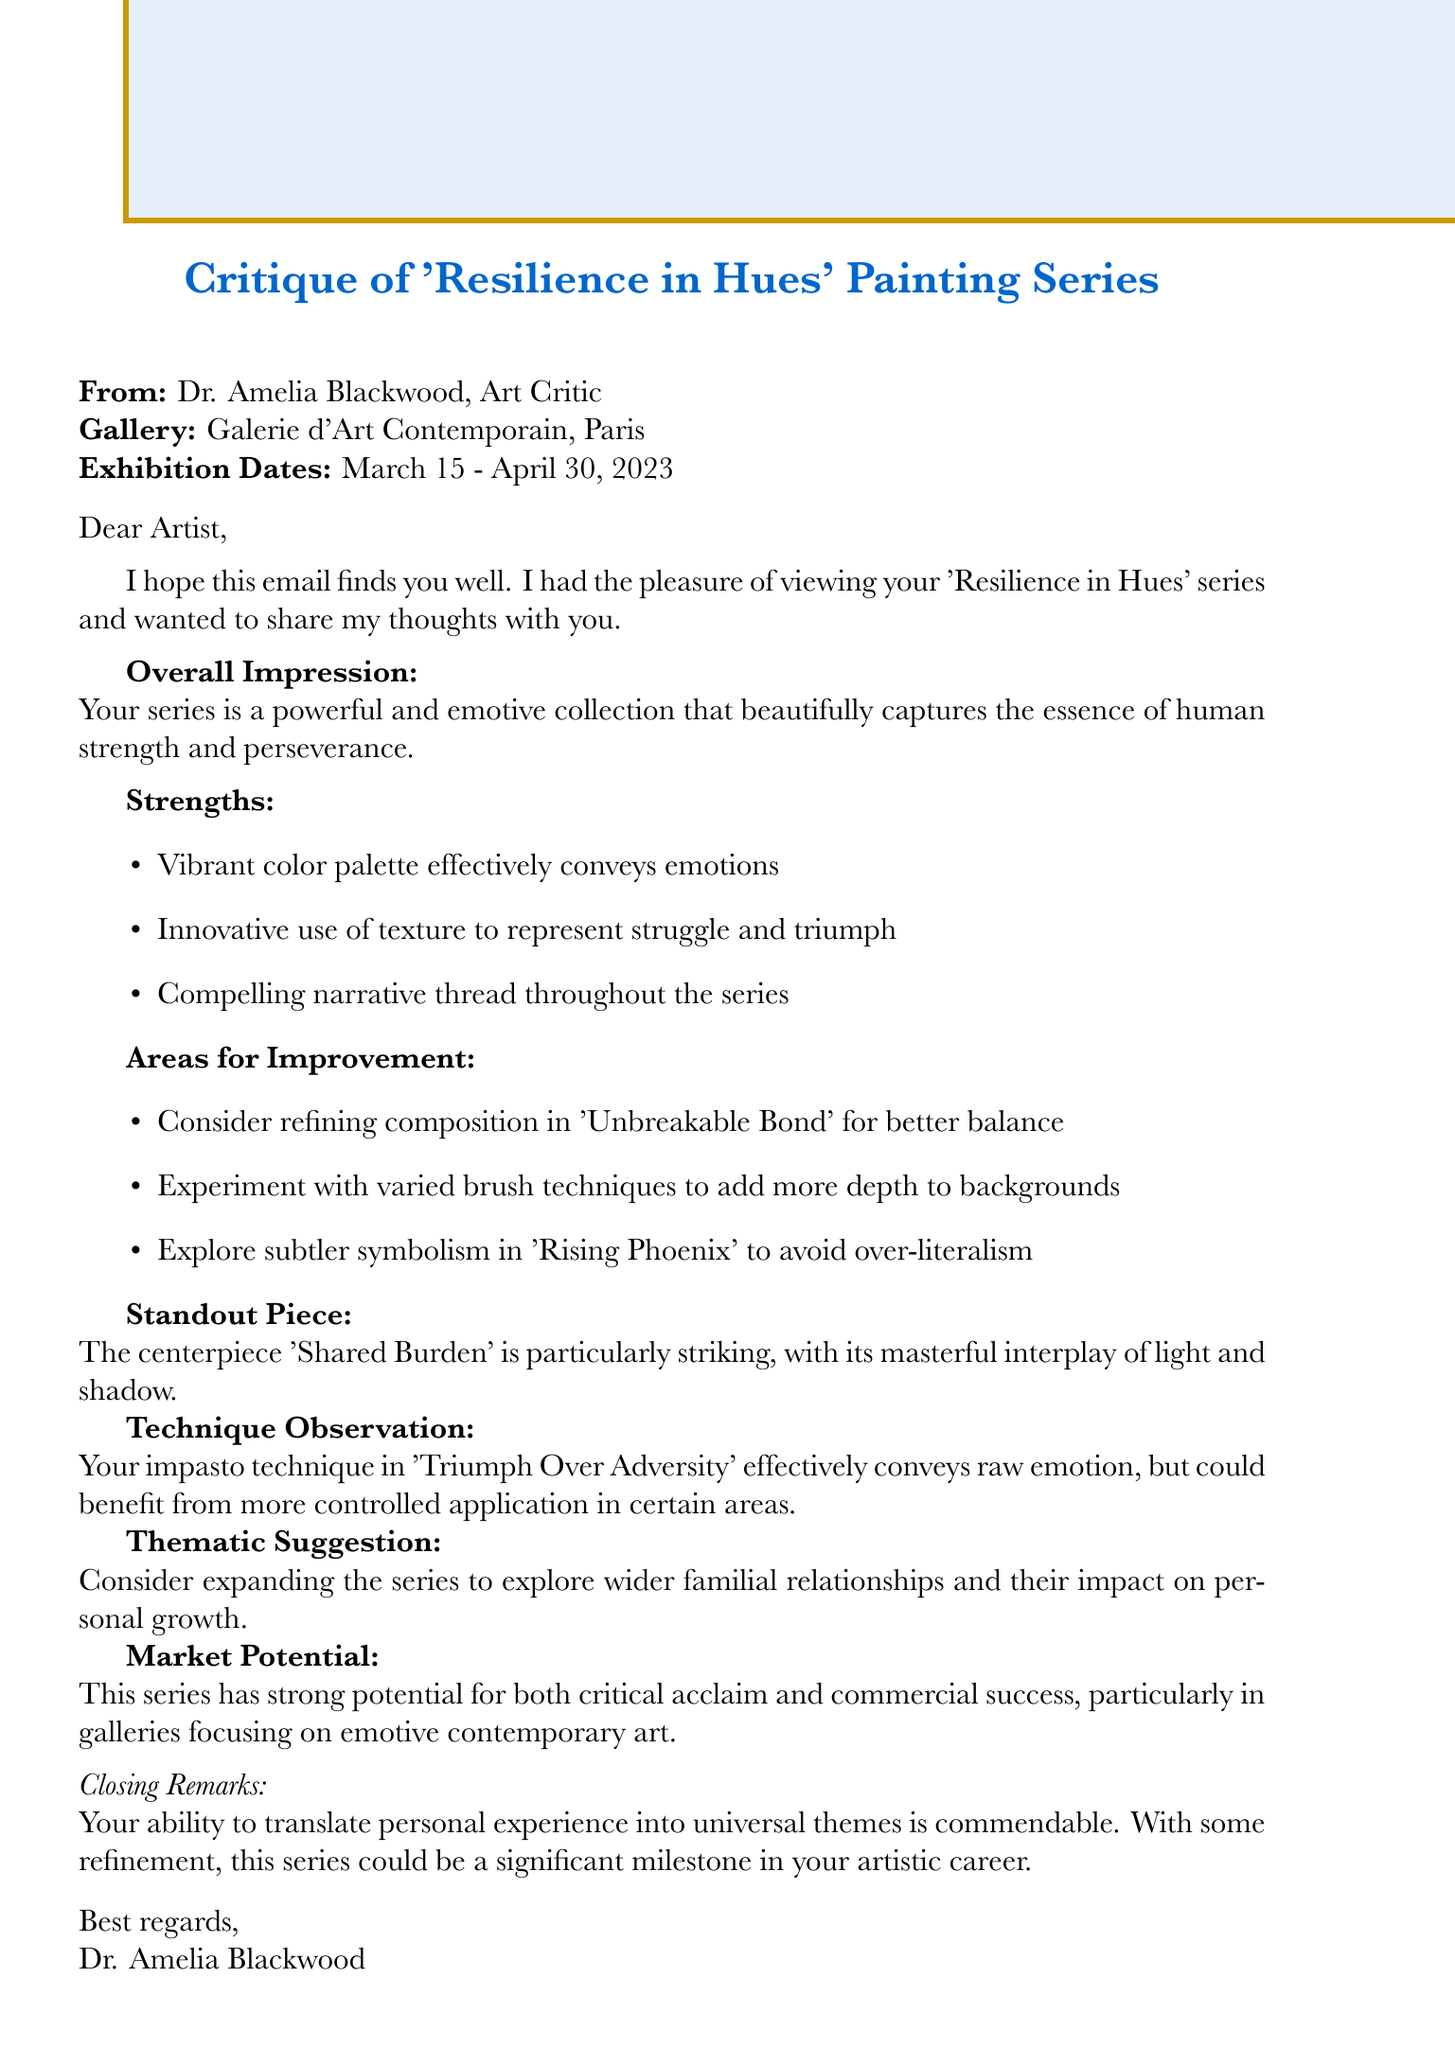What is the name of the painting series? The name of the painting series is mentioned in the document as 'Resilience in Hues'.
Answer: 'Resilience in Hues' Who is the critic that provided the feedback? The critic's name is stated in the document as Dr. Amelia Blackwood.
Answer: Dr. Amelia Blackwood What is the standout piece of the series? The standout piece mentioned in the document is 'Shared Burden'.
Answer: 'Shared Burden' Which technique did Dr. Amelia Blackwood comment on? The document references the impasto technique in 'Triumph Over Adversity'.
Answer: impasto technique What are the exhibition dates for the series? The exhibition dates are specifically listed as March 15 - April 30, 2023.
Answer: March 15 - April 30, 2023 What is one area for improvement suggested by the critic? The critic suggests refining the composition in 'Unbreakable Bond' for better balance.
Answer: refining composition in 'Unbreakable Bond' What emotion does the vibrant color palette aim to convey? The vibrant color palette is noted for effectively conveying emotions.
Answer: emotions What thematic suggestion did the critic make? The thematic suggestion mentioned discusses expanding the series to explore wider familial relationships.
Answer: wider familial relationships What is the overall impression given by the critic? The overall impression includes that the series beautifully captures the essence of human strength and perseverance.
Answer: captures the essence of human strength and perseverance 